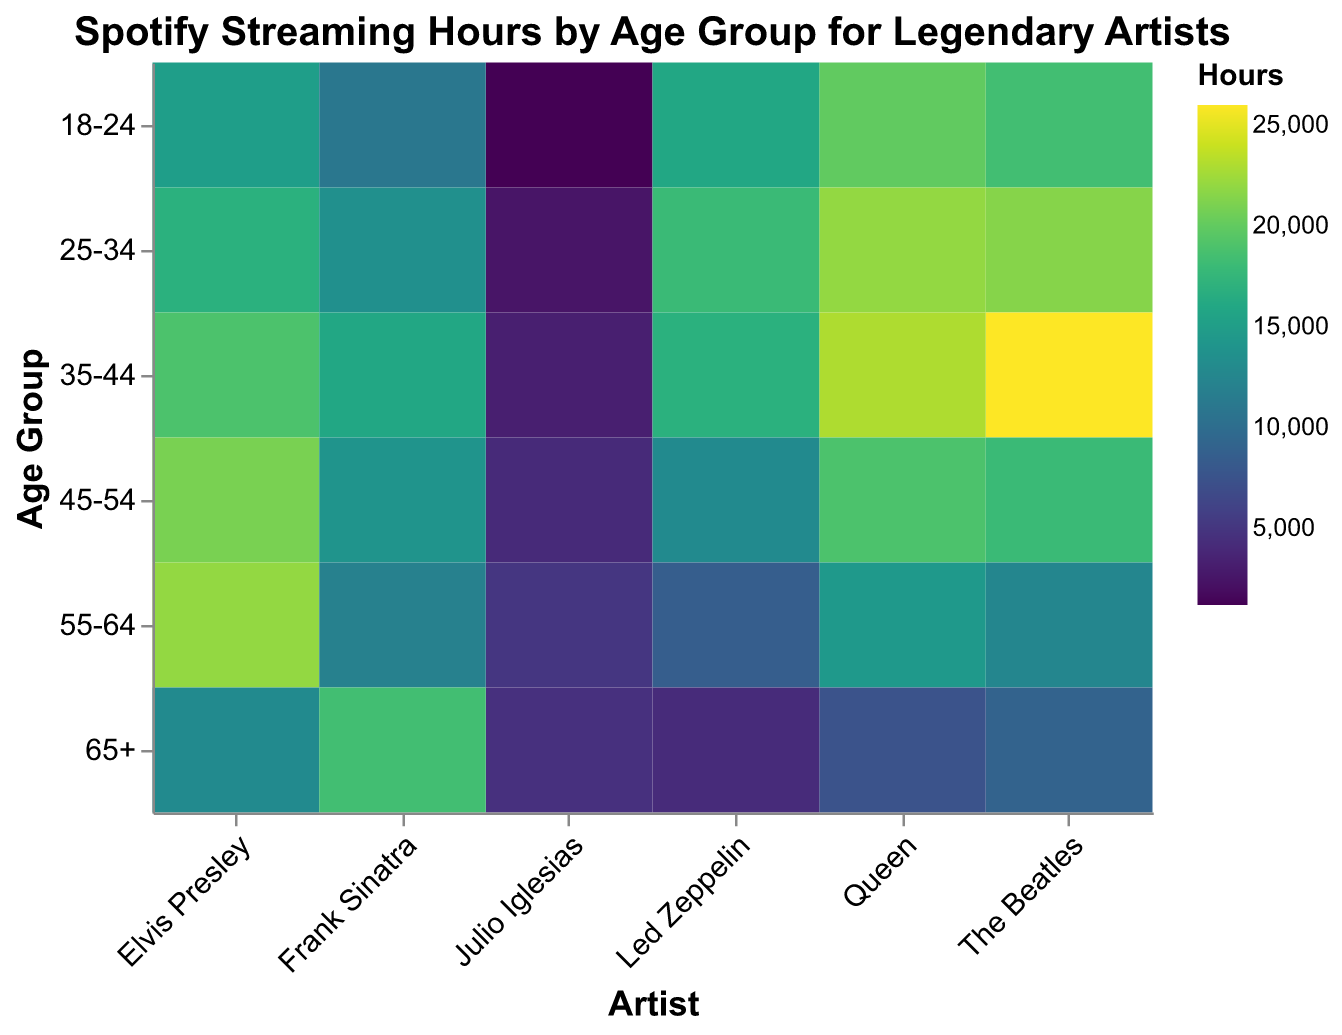How many hours did people aged 18-24 listen to Julio Iglesias? The heatmap shows streaming hours across different age groups for various artists. Look for the '18-24' row and 'Julio Iglesias' column intersection to find the number of hours listened.
Answer: 1200 Which artist has the most streaming hours in the 35-44 age group? Identify the '35-44' row in the heatmap and compare the streaming hours across all artists in this age group to find the maximum value.
Answer: The Beatles Compare the streaming hours of Elvis Presley and Queen for the 55-64 age group. Which artist has more hours? Locate the '55-64' row in the heatmap and compare the streaming hours of Elvis Presley and Queen to determine which artist has more hours.
Answer: Elvis Presley What is the average streaming hours for Julio Iglesias across all age groups? Sum the streaming hours for Julio Iglesias across all age groups and divide by the number of age groups (6) to find the average: (1200 + 2500 + 3200 + 4100 + 5000 + 4600) / 6.
Answer: 3433.33 Which age group listens to Frank Sinatra the most, and what are the hours? Examine the heatmap for the highest value in the 'Frank Sinatra' column and identify the corresponding age group.
Answer: 65+, 18500 What is the total number of streaming hours for Led Zeppelin across all age groups? Sum the streaming hours for Led Zeppelin across all age groups: 16000 + 18000 + 17000 + 13000 + 8500 + 4200.
Answer: 76700 How does the popularity of The Beatles change from the 18-24 age group to the 65+ age group? Compare the streaming hours for The Beatles in the '18-24' and '65+' age groups to observe the change: 18500 (18-24) vs. 9000 (65+).
Answer: Decreases from 18500 to 9000 Among the six artists listed, who has the lowest streaming hours in the 25-34 age group? Look at the '25-34' row in the heatmap and compare the streaming hours for all artists to find the minimum value.
Answer: Julio Iglesias Which artist shows the most uniform (least variable) streaming hours across all age groups? Examine the streaming hours for each artist across all age groups and identify the artist with the least variation in values.
Answer: Frank Sinatra 